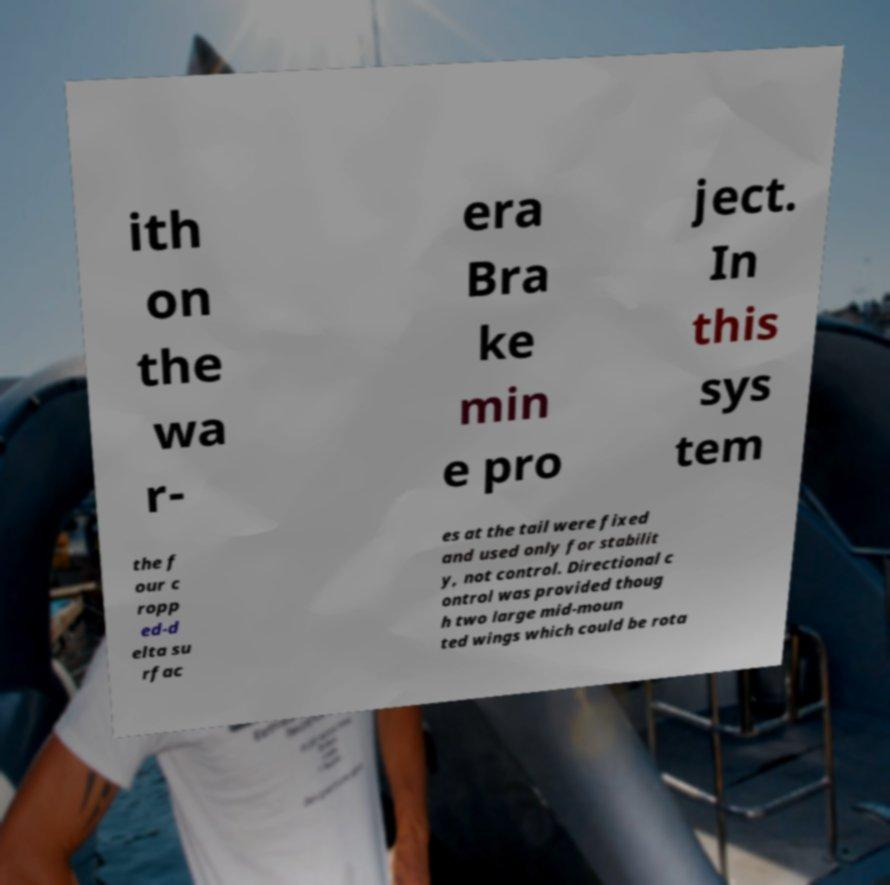Can you accurately transcribe the text from the provided image for me? ith on the wa r- era Bra ke min e pro ject. In this sys tem the f our c ropp ed-d elta su rfac es at the tail were fixed and used only for stabilit y, not control. Directional c ontrol was provided thoug h two large mid-moun ted wings which could be rota 